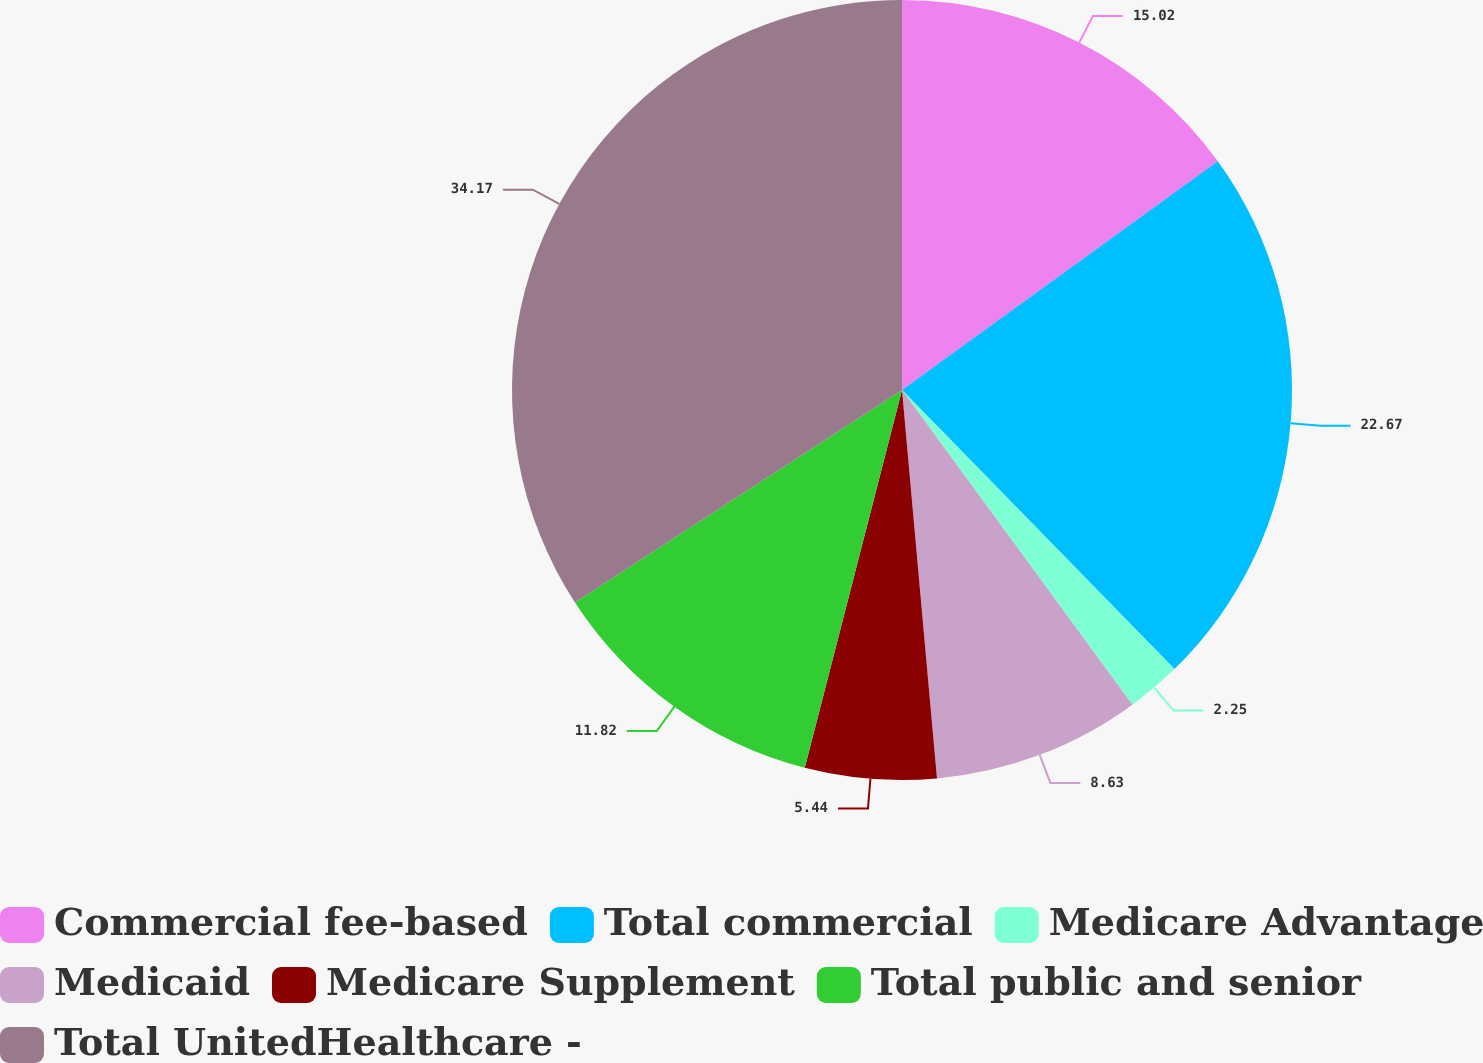Convert chart. <chart><loc_0><loc_0><loc_500><loc_500><pie_chart><fcel>Commercial fee-based<fcel>Total commercial<fcel>Medicare Advantage<fcel>Medicaid<fcel>Medicare Supplement<fcel>Total public and senior<fcel>Total UnitedHealthcare -<nl><fcel>15.02%<fcel>22.67%<fcel>2.25%<fcel>8.63%<fcel>5.44%<fcel>11.82%<fcel>34.17%<nl></chart> 